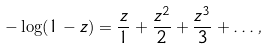Convert formula to latex. <formula><loc_0><loc_0><loc_500><loc_500>- \log ( 1 - z ) = \frac { z } { 1 } + \frac { z ^ { 2 } } { 2 } + \frac { z ^ { 3 } } { 3 } + \dots ,</formula> 